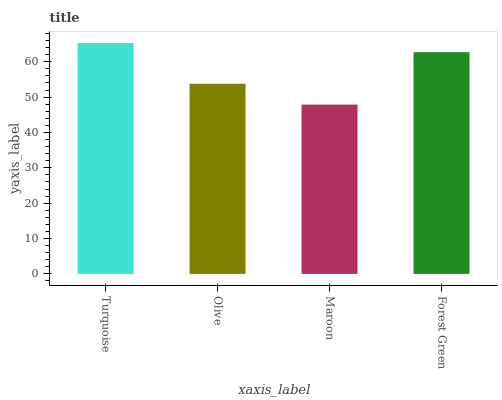Is Maroon the minimum?
Answer yes or no. Yes. Is Turquoise the maximum?
Answer yes or no. Yes. Is Olive the minimum?
Answer yes or no. No. Is Olive the maximum?
Answer yes or no. No. Is Turquoise greater than Olive?
Answer yes or no. Yes. Is Olive less than Turquoise?
Answer yes or no. Yes. Is Olive greater than Turquoise?
Answer yes or no. No. Is Turquoise less than Olive?
Answer yes or no. No. Is Forest Green the high median?
Answer yes or no. Yes. Is Olive the low median?
Answer yes or no. Yes. Is Olive the high median?
Answer yes or no. No. Is Turquoise the low median?
Answer yes or no. No. 